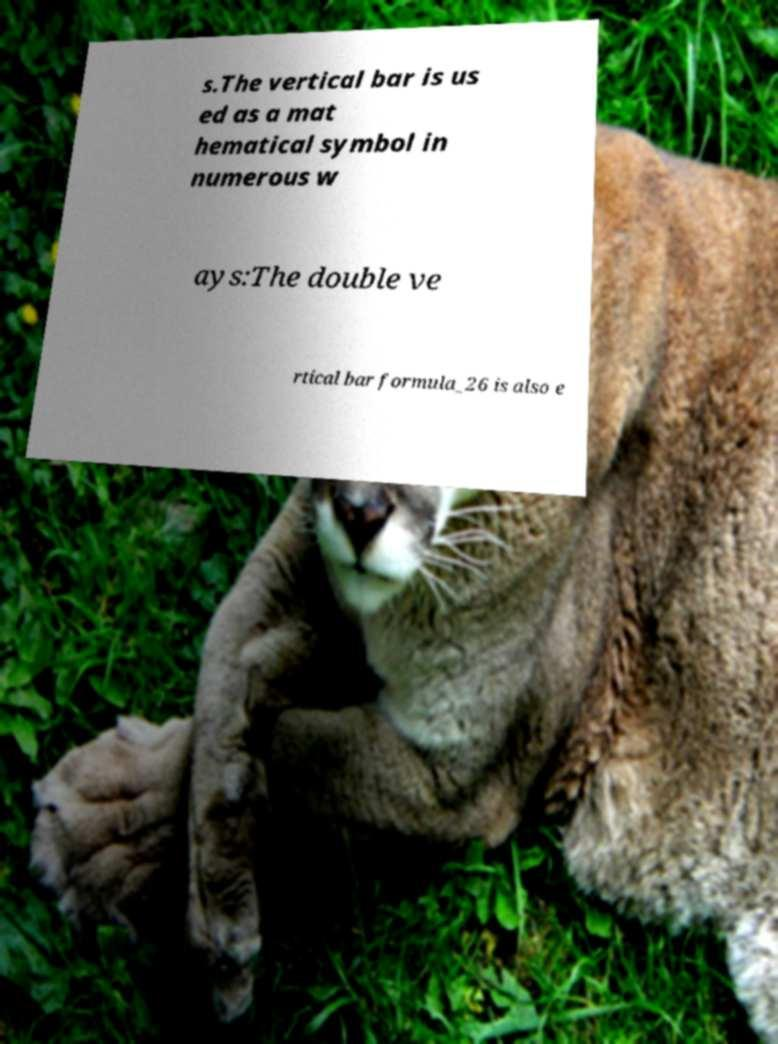Could you assist in decoding the text presented in this image and type it out clearly? s.The vertical bar is us ed as a mat hematical symbol in numerous w ays:The double ve rtical bar formula_26 is also e 